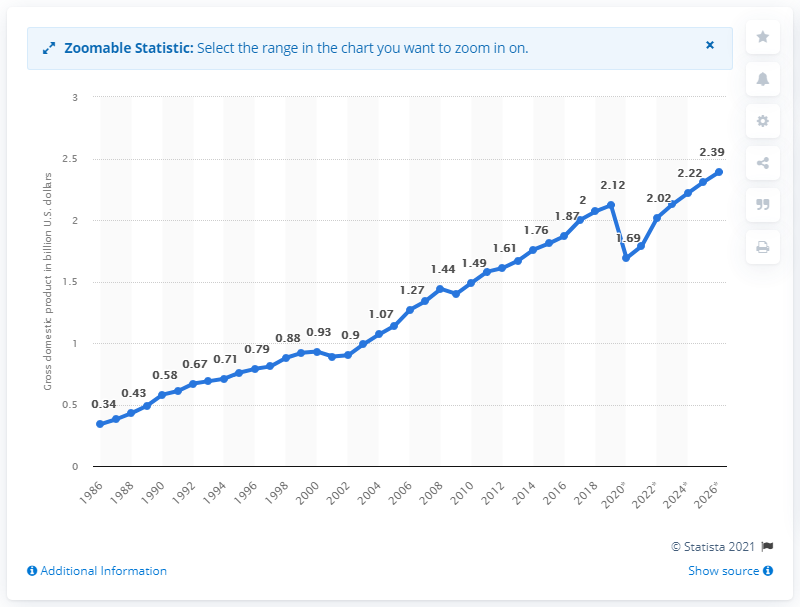Give some essential details in this illustration. In 2019, Saint Lucia's Gross Domestic Product (GDP) was $2.13 billion. 